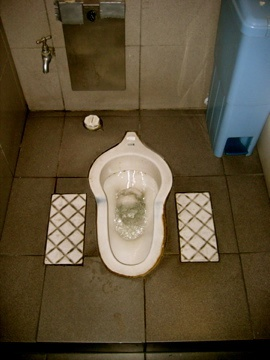Describe the objects in this image and their specific colors. I can see a toilet in black, tan, and lightgray tones in this image. 